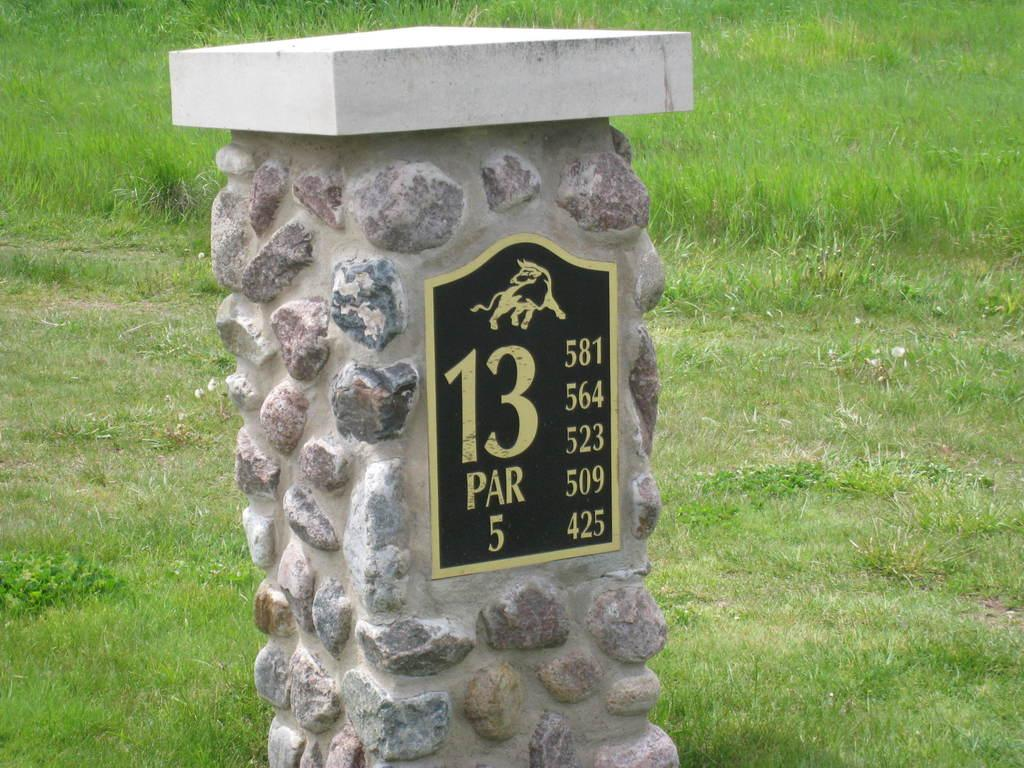What is the main object in the image? There is a stone stand in the image. What can be seen on the stone stand? Something is written on the stone stand. What type of vegetation is visible in the background of the image? There is green grass in the background of the image. Is there a kitten playing on the stone stand in the image? No, there is no kitten present in the image. 